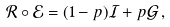<formula> <loc_0><loc_0><loc_500><loc_500>\mathcal { R } \circ \mathcal { E } = ( 1 - p ) \mathcal { I } + p \mathcal { G } \, ,</formula> 